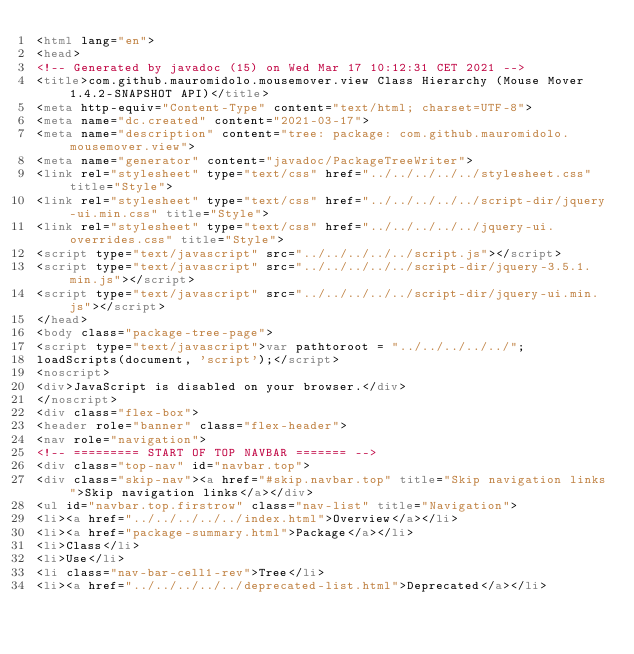Convert code to text. <code><loc_0><loc_0><loc_500><loc_500><_HTML_><html lang="en">
<head>
<!-- Generated by javadoc (15) on Wed Mar 17 10:12:31 CET 2021 -->
<title>com.github.mauromidolo.mousemover.view Class Hierarchy (Mouse Mover 1.4.2-SNAPSHOT API)</title>
<meta http-equiv="Content-Type" content="text/html; charset=UTF-8">
<meta name="dc.created" content="2021-03-17">
<meta name="description" content="tree: package: com.github.mauromidolo.mousemover.view">
<meta name="generator" content="javadoc/PackageTreeWriter">
<link rel="stylesheet" type="text/css" href="../../../../../stylesheet.css" title="Style">
<link rel="stylesheet" type="text/css" href="../../../../../script-dir/jquery-ui.min.css" title="Style">
<link rel="stylesheet" type="text/css" href="../../../../../jquery-ui.overrides.css" title="Style">
<script type="text/javascript" src="../../../../../script.js"></script>
<script type="text/javascript" src="../../../../../script-dir/jquery-3.5.1.min.js"></script>
<script type="text/javascript" src="../../../../../script-dir/jquery-ui.min.js"></script>
</head>
<body class="package-tree-page">
<script type="text/javascript">var pathtoroot = "../../../../../";
loadScripts(document, 'script');</script>
<noscript>
<div>JavaScript is disabled on your browser.</div>
</noscript>
<div class="flex-box">
<header role="banner" class="flex-header">
<nav role="navigation">
<!-- ========= START OF TOP NAVBAR ======= -->
<div class="top-nav" id="navbar.top">
<div class="skip-nav"><a href="#skip.navbar.top" title="Skip navigation links">Skip navigation links</a></div>
<ul id="navbar.top.firstrow" class="nav-list" title="Navigation">
<li><a href="../../../../../index.html">Overview</a></li>
<li><a href="package-summary.html">Package</a></li>
<li>Class</li>
<li>Use</li>
<li class="nav-bar-cell1-rev">Tree</li>
<li><a href="../../../../../deprecated-list.html">Deprecated</a></li></code> 